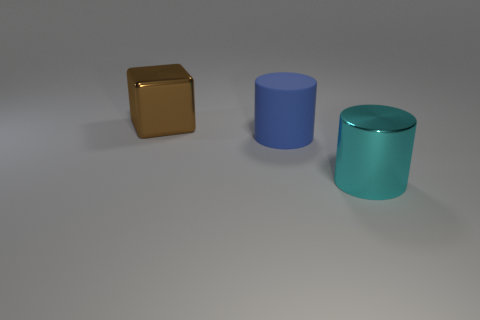Is there any other thing that is made of the same material as the blue thing?
Your answer should be compact. No. There is a big metal object that is right of the large object that is to the left of the blue matte cylinder; are there any large blue matte cylinders behind it?
Your response must be concise. Yes. How many matte objects are either brown cubes or small gray spheres?
Your response must be concise. 0. How many other objects are the same shape as the big matte object?
Your response must be concise. 1. Is the number of large gray rubber balls greater than the number of metallic cylinders?
Make the answer very short. No. What is the size of the metal object left of the cylinder behind the large shiny thing in front of the large block?
Your answer should be very brief. Large. What number of objects are either big cyan metallic cylinders or things that are to the left of the large cyan object?
Offer a very short reply. 3. What number of other things are the same size as the brown metallic block?
Keep it short and to the point. 2. What is the material of the other thing that is the same shape as the blue matte thing?
Make the answer very short. Metal. Are there more big blue matte cylinders to the left of the metallic cylinder than big brown cylinders?
Your response must be concise. Yes. 